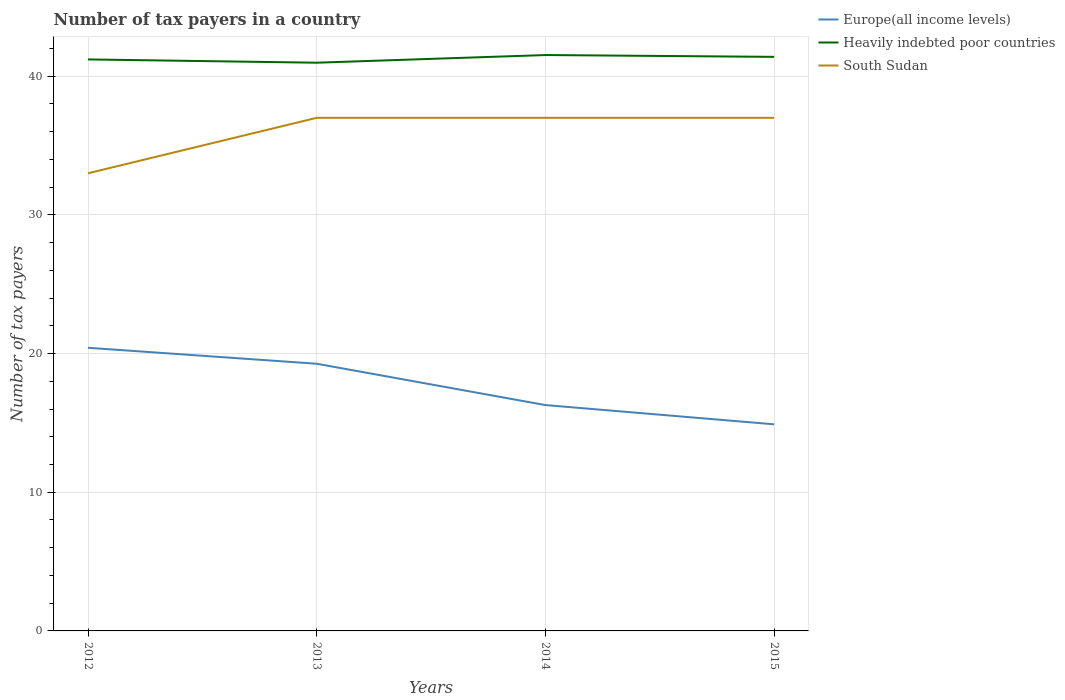Does the line corresponding to Europe(all income levels) intersect with the line corresponding to Heavily indebted poor countries?
Give a very brief answer. No. Across all years, what is the maximum number of tax payers in in Europe(all income levels)?
Make the answer very short. 14.9. In which year was the number of tax payers in in South Sudan maximum?
Give a very brief answer. 2012. What is the total number of tax payers in in Heavily indebted poor countries in the graph?
Make the answer very short. -0.32. What is the difference between the highest and the second highest number of tax payers in in Europe(all income levels)?
Offer a very short reply. 5.52. What is the difference between the highest and the lowest number of tax payers in in Heavily indebted poor countries?
Your answer should be very brief. 2. Is the number of tax payers in in Europe(all income levels) strictly greater than the number of tax payers in in Heavily indebted poor countries over the years?
Your answer should be compact. Yes. How many years are there in the graph?
Ensure brevity in your answer.  4. Are the values on the major ticks of Y-axis written in scientific E-notation?
Your answer should be compact. No. Does the graph contain grids?
Provide a short and direct response. Yes. How many legend labels are there?
Give a very brief answer. 3. How are the legend labels stacked?
Ensure brevity in your answer.  Vertical. What is the title of the graph?
Your response must be concise. Number of tax payers in a country. What is the label or title of the Y-axis?
Offer a very short reply. Number of tax payers. What is the Number of tax payers of Europe(all income levels) in 2012?
Keep it short and to the point. 20.42. What is the Number of tax payers of Heavily indebted poor countries in 2012?
Provide a short and direct response. 41.21. What is the Number of tax payers of South Sudan in 2012?
Provide a succinct answer. 33. What is the Number of tax payers of Europe(all income levels) in 2013?
Provide a short and direct response. 19.27. What is the Number of tax payers of Heavily indebted poor countries in 2013?
Offer a terse response. 40.97. What is the Number of tax payers of South Sudan in 2013?
Ensure brevity in your answer.  37. What is the Number of tax payers of Europe(all income levels) in 2014?
Provide a succinct answer. 16.29. What is the Number of tax payers in Heavily indebted poor countries in 2014?
Your answer should be compact. 41.53. What is the Number of tax payers of Europe(all income levels) in 2015?
Your answer should be very brief. 14.9. What is the Number of tax payers of Heavily indebted poor countries in 2015?
Your answer should be compact. 41.39. What is the Number of tax payers of South Sudan in 2015?
Provide a succinct answer. 37. Across all years, what is the maximum Number of tax payers in Europe(all income levels)?
Ensure brevity in your answer.  20.42. Across all years, what is the maximum Number of tax payers of Heavily indebted poor countries?
Give a very brief answer. 41.53. Across all years, what is the minimum Number of tax payers in Europe(all income levels)?
Offer a terse response. 14.9. Across all years, what is the minimum Number of tax payers of Heavily indebted poor countries?
Ensure brevity in your answer.  40.97. What is the total Number of tax payers of Europe(all income levels) in the graph?
Your response must be concise. 70.87. What is the total Number of tax payers of Heavily indebted poor countries in the graph?
Your response must be concise. 165.11. What is the total Number of tax payers of South Sudan in the graph?
Make the answer very short. 144. What is the difference between the Number of tax payers in Europe(all income levels) in 2012 and that in 2013?
Keep it short and to the point. 1.15. What is the difference between the Number of tax payers in Heavily indebted poor countries in 2012 and that in 2013?
Offer a terse response. 0.24. What is the difference between the Number of tax payers of South Sudan in 2012 and that in 2013?
Give a very brief answer. -4. What is the difference between the Number of tax payers in Europe(all income levels) in 2012 and that in 2014?
Your answer should be compact. 4.13. What is the difference between the Number of tax payers in Heavily indebted poor countries in 2012 and that in 2014?
Keep it short and to the point. -0.32. What is the difference between the Number of tax payers in South Sudan in 2012 and that in 2014?
Make the answer very short. -4. What is the difference between the Number of tax payers in Europe(all income levels) in 2012 and that in 2015?
Provide a succinct answer. 5.52. What is the difference between the Number of tax payers of Heavily indebted poor countries in 2012 and that in 2015?
Provide a succinct answer. -0.18. What is the difference between the Number of tax payers in South Sudan in 2012 and that in 2015?
Keep it short and to the point. -4. What is the difference between the Number of tax payers of Europe(all income levels) in 2013 and that in 2014?
Your answer should be compact. 2.98. What is the difference between the Number of tax payers of Heavily indebted poor countries in 2013 and that in 2014?
Offer a terse response. -0.55. What is the difference between the Number of tax payers of South Sudan in 2013 and that in 2014?
Make the answer very short. 0. What is the difference between the Number of tax payers of Europe(all income levels) in 2013 and that in 2015?
Ensure brevity in your answer.  4.37. What is the difference between the Number of tax payers of Heavily indebted poor countries in 2013 and that in 2015?
Offer a terse response. -0.42. What is the difference between the Number of tax payers of Europe(all income levels) in 2014 and that in 2015?
Make the answer very short. 1.39. What is the difference between the Number of tax payers in Heavily indebted poor countries in 2014 and that in 2015?
Your response must be concise. 0.13. What is the difference between the Number of tax payers of Europe(all income levels) in 2012 and the Number of tax payers of Heavily indebted poor countries in 2013?
Provide a succinct answer. -20.56. What is the difference between the Number of tax payers in Europe(all income levels) in 2012 and the Number of tax payers in South Sudan in 2013?
Make the answer very short. -16.58. What is the difference between the Number of tax payers of Heavily indebted poor countries in 2012 and the Number of tax payers of South Sudan in 2013?
Your answer should be very brief. 4.21. What is the difference between the Number of tax payers of Europe(all income levels) in 2012 and the Number of tax payers of Heavily indebted poor countries in 2014?
Offer a terse response. -21.11. What is the difference between the Number of tax payers in Europe(all income levels) in 2012 and the Number of tax payers in South Sudan in 2014?
Provide a short and direct response. -16.58. What is the difference between the Number of tax payers in Heavily indebted poor countries in 2012 and the Number of tax payers in South Sudan in 2014?
Make the answer very short. 4.21. What is the difference between the Number of tax payers in Europe(all income levels) in 2012 and the Number of tax payers in Heavily indebted poor countries in 2015?
Provide a succinct answer. -20.98. What is the difference between the Number of tax payers in Europe(all income levels) in 2012 and the Number of tax payers in South Sudan in 2015?
Offer a terse response. -16.58. What is the difference between the Number of tax payers of Heavily indebted poor countries in 2012 and the Number of tax payers of South Sudan in 2015?
Offer a very short reply. 4.21. What is the difference between the Number of tax payers of Europe(all income levels) in 2013 and the Number of tax payers of Heavily indebted poor countries in 2014?
Your answer should be very brief. -22.26. What is the difference between the Number of tax payers of Europe(all income levels) in 2013 and the Number of tax payers of South Sudan in 2014?
Your response must be concise. -17.73. What is the difference between the Number of tax payers of Heavily indebted poor countries in 2013 and the Number of tax payers of South Sudan in 2014?
Keep it short and to the point. 3.97. What is the difference between the Number of tax payers in Europe(all income levels) in 2013 and the Number of tax payers in Heavily indebted poor countries in 2015?
Give a very brief answer. -22.13. What is the difference between the Number of tax payers in Europe(all income levels) in 2013 and the Number of tax payers in South Sudan in 2015?
Provide a succinct answer. -17.73. What is the difference between the Number of tax payers in Heavily indebted poor countries in 2013 and the Number of tax payers in South Sudan in 2015?
Ensure brevity in your answer.  3.97. What is the difference between the Number of tax payers in Europe(all income levels) in 2014 and the Number of tax payers in Heavily indebted poor countries in 2015?
Make the answer very short. -25.11. What is the difference between the Number of tax payers of Europe(all income levels) in 2014 and the Number of tax payers of South Sudan in 2015?
Give a very brief answer. -20.71. What is the difference between the Number of tax payers in Heavily indebted poor countries in 2014 and the Number of tax payers in South Sudan in 2015?
Provide a short and direct response. 4.53. What is the average Number of tax payers of Europe(all income levels) per year?
Your answer should be compact. 17.72. What is the average Number of tax payers of Heavily indebted poor countries per year?
Provide a short and direct response. 41.28. What is the average Number of tax payers in South Sudan per year?
Give a very brief answer. 36. In the year 2012, what is the difference between the Number of tax payers of Europe(all income levels) and Number of tax payers of Heavily indebted poor countries?
Ensure brevity in your answer.  -20.79. In the year 2012, what is the difference between the Number of tax payers of Europe(all income levels) and Number of tax payers of South Sudan?
Provide a succinct answer. -12.58. In the year 2012, what is the difference between the Number of tax payers in Heavily indebted poor countries and Number of tax payers in South Sudan?
Make the answer very short. 8.21. In the year 2013, what is the difference between the Number of tax payers in Europe(all income levels) and Number of tax payers in Heavily indebted poor countries?
Give a very brief answer. -21.71. In the year 2013, what is the difference between the Number of tax payers in Europe(all income levels) and Number of tax payers in South Sudan?
Provide a short and direct response. -17.73. In the year 2013, what is the difference between the Number of tax payers of Heavily indebted poor countries and Number of tax payers of South Sudan?
Your answer should be very brief. 3.97. In the year 2014, what is the difference between the Number of tax payers of Europe(all income levels) and Number of tax payers of Heavily indebted poor countries?
Provide a short and direct response. -25.24. In the year 2014, what is the difference between the Number of tax payers in Europe(all income levels) and Number of tax payers in South Sudan?
Provide a succinct answer. -20.71. In the year 2014, what is the difference between the Number of tax payers of Heavily indebted poor countries and Number of tax payers of South Sudan?
Provide a short and direct response. 4.53. In the year 2015, what is the difference between the Number of tax payers in Europe(all income levels) and Number of tax payers in Heavily indebted poor countries?
Provide a short and direct response. -26.5. In the year 2015, what is the difference between the Number of tax payers of Europe(all income levels) and Number of tax payers of South Sudan?
Your answer should be compact. -22.1. In the year 2015, what is the difference between the Number of tax payers of Heavily indebted poor countries and Number of tax payers of South Sudan?
Your answer should be very brief. 4.39. What is the ratio of the Number of tax payers in Europe(all income levels) in 2012 to that in 2013?
Provide a short and direct response. 1.06. What is the ratio of the Number of tax payers of South Sudan in 2012 to that in 2013?
Give a very brief answer. 0.89. What is the ratio of the Number of tax payers in Europe(all income levels) in 2012 to that in 2014?
Provide a short and direct response. 1.25. What is the ratio of the Number of tax payers of Heavily indebted poor countries in 2012 to that in 2014?
Provide a succinct answer. 0.99. What is the ratio of the Number of tax payers in South Sudan in 2012 to that in 2014?
Provide a short and direct response. 0.89. What is the ratio of the Number of tax payers of Europe(all income levels) in 2012 to that in 2015?
Give a very brief answer. 1.37. What is the ratio of the Number of tax payers in South Sudan in 2012 to that in 2015?
Keep it short and to the point. 0.89. What is the ratio of the Number of tax payers in Europe(all income levels) in 2013 to that in 2014?
Ensure brevity in your answer.  1.18. What is the ratio of the Number of tax payers in Heavily indebted poor countries in 2013 to that in 2014?
Provide a succinct answer. 0.99. What is the ratio of the Number of tax payers in South Sudan in 2013 to that in 2014?
Offer a very short reply. 1. What is the ratio of the Number of tax payers of Europe(all income levels) in 2013 to that in 2015?
Provide a succinct answer. 1.29. What is the ratio of the Number of tax payers in South Sudan in 2013 to that in 2015?
Provide a short and direct response. 1. What is the ratio of the Number of tax payers of Europe(all income levels) in 2014 to that in 2015?
Provide a short and direct response. 1.09. What is the ratio of the Number of tax payers of Heavily indebted poor countries in 2014 to that in 2015?
Make the answer very short. 1. What is the ratio of the Number of tax payers in South Sudan in 2014 to that in 2015?
Your answer should be very brief. 1. What is the difference between the highest and the second highest Number of tax payers in Europe(all income levels)?
Offer a terse response. 1.15. What is the difference between the highest and the second highest Number of tax payers of Heavily indebted poor countries?
Ensure brevity in your answer.  0.13. What is the difference between the highest and the second highest Number of tax payers in South Sudan?
Your answer should be very brief. 0. What is the difference between the highest and the lowest Number of tax payers in Europe(all income levels)?
Offer a very short reply. 5.52. What is the difference between the highest and the lowest Number of tax payers in Heavily indebted poor countries?
Make the answer very short. 0.55. 